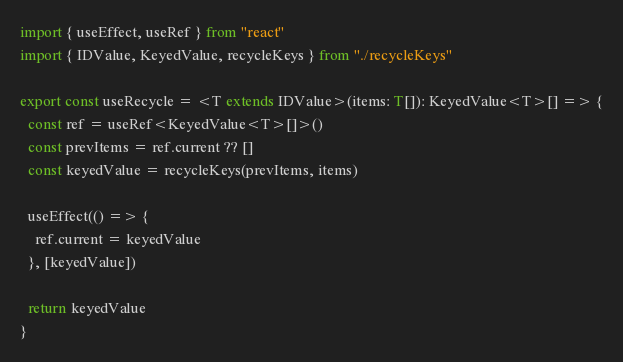<code> <loc_0><loc_0><loc_500><loc_500><_TypeScript_>import { useEffect, useRef } from "react"
import { IDValue, KeyedValue, recycleKeys } from "./recycleKeys"

export const useRecycle = <T extends IDValue>(items: T[]): KeyedValue<T>[] => {
  const ref = useRef<KeyedValue<T>[]>()
  const prevItems = ref.current ?? []
  const keyedValue = recycleKeys(prevItems, items)

  useEffect(() => {
    ref.current = keyedValue
  }, [keyedValue])

  return keyedValue
}
</code> 